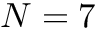<formula> <loc_0><loc_0><loc_500><loc_500>N = 7</formula> 